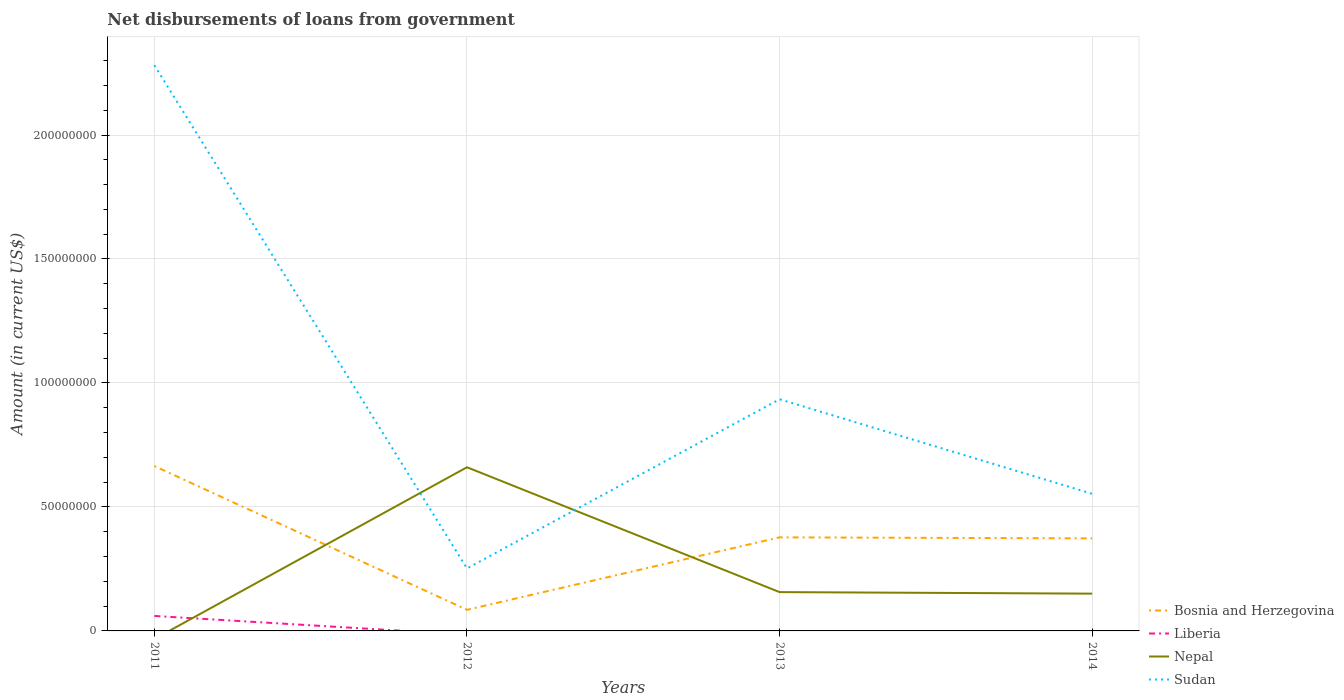How many different coloured lines are there?
Give a very brief answer. 4. Is the number of lines equal to the number of legend labels?
Provide a short and direct response. No. Across all years, what is the maximum amount of loan disbursed from government in Bosnia and Herzegovina?
Offer a terse response. 8.51e+06. What is the total amount of loan disbursed from government in Bosnia and Herzegovina in the graph?
Your answer should be compact. -2.88e+07. What is the difference between the highest and the second highest amount of loan disbursed from government in Sudan?
Make the answer very short. 2.03e+08. What is the difference between the highest and the lowest amount of loan disbursed from government in Bosnia and Herzegovina?
Keep it short and to the point. 2. Is the amount of loan disbursed from government in Nepal strictly greater than the amount of loan disbursed from government in Bosnia and Herzegovina over the years?
Ensure brevity in your answer.  No. How many lines are there?
Offer a very short reply. 4. Does the graph contain any zero values?
Provide a short and direct response. Yes. Where does the legend appear in the graph?
Your answer should be very brief. Bottom right. How are the legend labels stacked?
Provide a succinct answer. Vertical. What is the title of the graph?
Provide a short and direct response. Net disbursements of loans from government. Does "East Asia (all income levels)" appear as one of the legend labels in the graph?
Your response must be concise. No. What is the label or title of the X-axis?
Make the answer very short. Years. What is the Amount (in current US$) in Bosnia and Herzegovina in 2011?
Offer a very short reply. 6.65e+07. What is the Amount (in current US$) in Liberia in 2011?
Provide a succinct answer. 6.04e+06. What is the Amount (in current US$) of Nepal in 2011?
Provide a succinct answer. 0. What is the Amount (in current US$) in Sudan in 2011?
Keep it short and to the point. 2.28e+08. What is the Amount (in current US$) in Bosnia and Herzegovina in 2012?
Provide a short and direct response. 8.51e+06. What is the Amount (in current US$) in Nepal in 2012?
Provide a succinct answer. 6.60e+07. What is the Amount (in current US$) in Sudan in 2012?
Give a very brief answer. 2.52e+07. What is the Amount (in current US$) in Bosnia and Herzegovina in 2013?
Provide a short and direct response. 3.77e+07. What is the Amount (in current US$) of Liberia in 2013?
Give a very brief answer. 0. What is the Amount (in current US$) of Nepal in 2013?
Offer a very short reply. 1.57e+07. What is the Amount (in current US$) of Sudan in 2013?
Offer a terse response. 9.34e+07. What is the Amount (in current US$) of Bosnia and Herzegovina in 2014?
Your answer should be very brief. 3.73e+07. What is the Amount (in current US$) of Nepal in 2014?
Your answer should be compact. 1.50e+07. What is the Amount (in current US$) in Sudan in 2014?
Make the answer very short. 5.53e+07. Across all years, what is the maximum Amount (in current US$) in Bosnia and Herzegovina?
Provide a succinct answer. 6.65e+07. Across all years, what is the maximum Amount (in current US$) of Liberia?
Keep it short and to the point. 6.04e+06. Across all years, what is the maximum Amount (in current US$) in Nepal?
Keep it short and to the point. 6.60e+07. Across all years, what is the maximum Amount (in current US$) of Sudan?
Provide a succinct answer. 2.28e+08. Across all years, what is the minimum Amount (in current US$) of Bosnia and Herzegovina?
Your answer should be compact. 8.51e+06. Across all years, what is the minimum Amount (in current US$) in Nepal?
Your answer should be compact. 0. Across all years, what is the minimum Amount (in current US$) in Sudan?
Your answer should be very brief. 2.52e+07. What is the total Amount (in current US$) in Bosnia and Herzegovina in the graph?
Provide a short and direct response. 1.50e+08. What is the total Amount (in current US$) in Liberia in the graph?
Your answer should be compact. 6.04e+06. What is the total Amount (in current US$) of Nepal in the graph?
Ensure brevity in your answer.  9.67e+07. What is the total Amount (in current US$) in Sudan in the graph?
Your answer should be compact. 4.02e+08. What is the difference between the Amount (in current US$) in Bosnia and Herzegovina in 2011 and that in 2012?
Provide a succinct answer. 5.80e+07. What is the difference between the Amount (in current US$) in Sudan in 2011 and that in 2012?
Your answer should be very brief. 2.03e+08. What is the difference between the Amount (in current US$) of Bosnia and Herzegovina in 2011 and that in 2013?
Your answer should be very brief. 2.87e+07. What is the difference between the Amount (in current US$) in Sudan in 2011 and that in 2013?
Your answer should be very brief. 1.35e+08. What is the difference between the Amount (in current US$) of Bosnia and Herzegovina in 2011 and that in 2014?
Your answer should be very brief. 2.92e+07. What is the difference between the Amount (in current US$) in Sudan in 2011 and that in 2014?
Offer a terse response. 1.73e+08. What is the difference between the Amount (in current US$) in Bosnia and Herzegovina in 2012 and that in 2013?
Provide a short and direct response. -2.92e+07. What is the difference between the Amount (in current US$) of Nepal in 2012 and that in 2013?
Ensure brevity in your answer.  5.04e+07. What is the difference between the Amount (in current US$) of Sudan in 2012 and that in 2013?
Offer a terse response. -6.82e+07. What is the difference between the Amount (in current US$) of Bosnia and Herzegovina in 2012 and that in 2014?
Your response must be concise. -2.88e+07. What is the difference between the Amount (in current US$) in Nepal in 2012 and that in 2014?
Keep it short and to the point. 5.10e+07. What is the difference between the Amount (in current US$) in Sudan in 2012 and that in 2014?
Your answer should be very brief. -3.01e+07. What is the difference between the Amount (in current US$) in Bosnia and Herzegovina in 2013 and that in 2014?
Make the answer very short. 4.12e+05. What is the difference between the Amount (in current US$) in Nepal in 2013 and that in 2014?
Offer a terse response. 6.17e+05. What is the difference between the Amount (in current US$) of Sudan in 2013 and that in 2014?
Keep it short and to the point. 3.81e+07. What is the difference between the Amount (in current US$) of Bosnia and Herzegovina in 2011 and the Amount (in current US$) of Nepal in 2012?
Ensure brevity in your answer.  4.78e+05. What is the difference between the Amount (in current US$) in Bosnia and Herzegovina in 2011 and the Amount (in current US$) in Sudan in 2012?
Make the answer very short. 4.13e+07. What is the difference between the Amount (in current US$) in Liberia in 2011 and the Amount (in current US$) in Nepal in 2012?
Make the answer very short. -6.00e+07. What is the difference between the Amount (in current US$) in Liberia in 2011 and the Amount (in current US$) in Sudan in 2012?
Give a very brief answer. -1.92e+07. What is the difference between the Amount (in current US$) of Bosnia and Herzegovina in 2011 and the Amount (in current US$) of Nepal in 2013?
Your answer should be compact. 5.08e+07. What is the difference between the Amount (in current US$) of Bosnia and Herzegovina in 2011 and the Amount (in current US$) of Sudan in 2013?
Give a very brief answer. -2.69e+07. What is the difference between the Amount (in current US$) in Liberia in 2011 and the Amount (in current US$) in Nepal in 2013?
Your answer should be compact. -9.61e+06. What is the difference between the Amount (in current US$) of Liberia in 2011 and the Amount (in current US$) of Sudan in 2013?
Keep it short and to the point. -8.74e+07. What is the difference between the Amount (in current US$) in Bosnia and Herzegovina in 2011 and the Amount (in current US$) in Nepal in 2014?
Ensure brevity in your answer.  5.14e+07. What is the difference between the Amount (in current US$) in Bosnia and Herzegovina in 2011 and the Amount (in current US$) in Sudan in 2014?
Keep it short and to the point. 1.12e+07. What is the difference between the Amount (in current US$) of Liberia in 2011 and the Amount (in current US$) of Nepal in 2014?
Keep it short and to the point. -9.00e+06. What is the difference between the Amount (in current US$) of Liberia in 2011 and the Amount (in current US$) of Sudan in 2014?
Provide a succinct answer. -4.93e+07. What is the difference between the Amount (in current US$) of Bosnia and Herzegovina in 2012 and the Amount (in current US$) of Nepal in 2013?
Make the answer very short. -7.14e+06. What is the difference between the Amount (in current US$) of Bosnia and Herzegovina in 2012 and the Amount (in current US$) of Sudan in 2013?
Your answer should be compact. -8.49e+07. What is the difference between the Amount (in current US$) in Nepal in 2012 and the Amount (in current US$) in Sudan in 2013?
Offer a terse response. -2.74e+07. What is the difference between the Amount (in current US$) of Bosnia and Herzegovina in 2012 and the Amount (in current US$) of Nepal in 2014?
Provide a short and direct response. -6.52e+06. What is the difference between the Amount (in current US$) of Bosnia and Herzegovina in 2012 and the Amount (in current US$) of Sudan in 2014?
Offer a very short reply. -4.68e+07. What is the difference between the Amount (in current US$) in Nepal in 2012 and the Amount (in current US$) in Sudan in 2014?
Offer a terse response. 1.07e+07. What is the difference between the Amount (in current US$) of Bosnia and Herzegovina in 2013 and the Amount (in current US$) of Nepal in 2014?
Provide a succinct answer. 2.27e+07. What is the difference between the Amount (in current US$) in Bosnia and Herzegovina in 2013 and the Amount (in current US$) in Sudan in 2014?
Your response must be concise. -1.76e+07. What is the difference between the Amount (in current US$) of Nepal in 2013 and the Amount (in current US$) of Sudan in 2014?
Make the answer very short. -3.96e+07. What is the average Amount (in current US$) of Bosnia and Herzegovina per year?
Give a very brief answer. 3.75e+07. What is the average Amount (in current US$) in Liberia per year?
Give a very brief answer. 1.51e+06. What is the average Amount (in current US$) in Nepal per year?
Keep it short and to the point. 2.42e+07. What is the average Amount (in current US$) of Sudan per year?
Your answer should be very brief. 1.01e+08. In the year 2011, what is the difference between the Amount (in current US$) in Bosnia and Herzegovina and Amount (in current US$) in Liberia?
Keep it short and to the point. 6.04e+07. In the year 2011, what is the difference between the Amount (in current US$) of Bosnia and Herzegovina and Amount (in current US$) of Sudan?
Provide a succinct answer. -1.62e+08. In the year 2011, what is the difference between the Amount (in current US$) in Liberia and Amount (in current US$) in Sudan?
Offer a very short reply. -2.22e+08. In the year 2012, what is the difference between the Amount (in current US$) in Bosnia and Herzegovina and Amount (in current US$) in Nepal?
Your answer should be compact. -5.75e+07. In the year 2012, what is the difference between the Amount (in current US$) of Bosnia and Herzegovina and Amount (in current US$) of Sudan?
Your answer should be very brief. -1.67e+07. In the year 2012, what is the difference between the Amount (in current US$) in Nepal and Amount (in current US$) in Sudan?
Your answer should be compact. 4.08e+07. In the year 2013, what is the difference between the Amount (in current US$) of Bosnia and Herzegovina and Amount (in current US$) of Nepal?
Offer a terse response. 2.21e+07. In the year 2013, what is the difference between the Amount (in current US$) of Bosnia and Herzegovina and Amount (in current US$) of Sudan?
Offer a very short reply. -5.57e+07. In the year 2013, what is the difference between the Amount (in current US$) in Nepal and Amount (in current US$) in Sudan?
Ensure brevity in your answer.  -7.78e+07. In the year 2014, what is the difference between the Amount (in current US$) of Bosnia and Herzegovina and Amount (in current US$) of Nepal?
Make the answer very short. 2.23e+07. In the year 2014, what is the difference between the Amount (in current US$) in Bosnia and Herzegovina and Amount (in current US$) in Sudan?
Provide a succinct answer. -1.80e+07. In the year 2014, what is the difference between the Amount (in current US$) in Nepal and Amount (in current US$) in Sudan?
Provide a succinct answer. -4.03e+07. What is the ratio of the Amount (in current US$) in Bosnia and Herzegovina in 2011 to that in 2012?
Your answer should be compact. 7.81. What is the ratio of the Amount (in current US$) of Sudan in 2011 to that in 2012?
Offer a terse response. 9.05. What is the ratio of the Amount (in current US$) of Bosnia and Herzegovina in 2011 to that in 2013?
Make the answer very short. 1.76. What is the ratio of the Amount (in current US$) of Sudan in 2011 to that in 2013?
Ensure brevity in your answer.  2.44. What is the ratio of the Amount (in current US$) of Bosnia and Herzegovina in 2011 to that in 2014?
Keep it short and to the point. 1.78. What is the ratio of the Amount (in current US$) in Sudan in 2011 to that in 2014?
Make the answer very short. 4.13. What is the ratio of the Amount (in current US$) of Bosnia and Herzegovina in 2012 to that in 2013?
Keep it short and to the point. 0.23. What is the ratio of the Amount (in current US$) in Nepal in 2012 to that in 2013?
Your answer should be compact. 4.22. What is the ratio of the Amount (in current US$) in Sudan in 2012 to that in 2013?
Your answer should be very brief. 0.27. What is the ratio of the Amount (in current US$) of Bosnia and Herzegovina in 2012 to that in 2014?
Ensure brevity in your answer.  0.23. What is the ratio of the Amount (in current US$) in Nepal in 2012 to that in 2014?
Provide a succinct answer. 4.39. What is the ratio of the Amount (in current US$) of Sudan in 2012 to that in 2014?
Offer a terse response. 0.46. What is the ratio of the Amount (in current US$) of Nepal in 2013 to that in 2014?
Make the answer very short. 1.04. What is the ratio of the Amount (in current US$) in Sudan in 2013 to that in 2014?
Provide a succinct answer. 1.69. What is the difference between the highest and the second highest Amount (in current US$) of Bosnia and Herzegovina?
Ensure brevity in your answer.  2.87e+07. What is the difference between the highest and the second highest Amount (in current US$) in Nepal?
Your response must be concise. 5.04e+07. What is the difference between the highest and the second highest Amount (in current US$) of Sudan?
Your answer should be very brief. 1.35e+08. What is the difference between the highest and the lowest Amount (in current US$) of Bosnia and Herzegovina?
Keep it short and to the point. 5.80e+07. What is the difference between the highest and the lowest Amount (in current US$) of Liberia?
Your answer should be very brief. 6.04e+06. What is the difference between the highest and the lowest Amount (in current US$) of Nepal?
Offer a very short reply. 6.60e+07. What is the difference between the highest and the lowest Amount (in current US$) of Sudan?
Keep it short and to the point. 2.03e+08. 